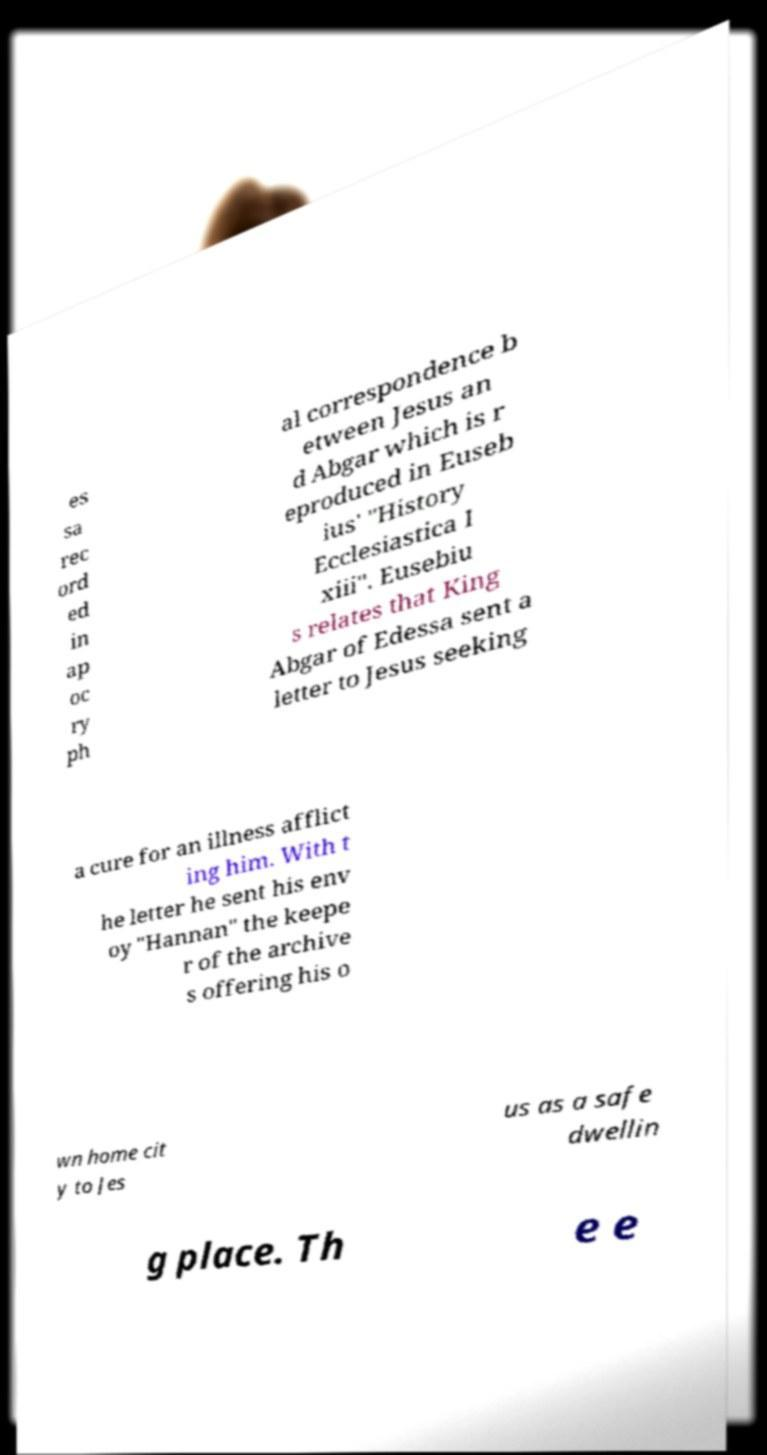Can you read and provide the text displayed in the image?This photo seems to have some interesting text. Can you extract and type it out for me? es sa rec ord ed in ap oc ry ph al correspondence b etween Jesus an d Abgar which is r eproduced in Euseb ius' "History Ecclesiastica I xiii". Eusebiu s relates that King Abgar of Edessa sent a letter to Jesus seeking a cure for an illness afflict ing him. With t he letter he sent his env oy "Hannan" the keepe r of the archive s offering his o wn home cit y to Jes us as a safe dwellin g place. Th e e 